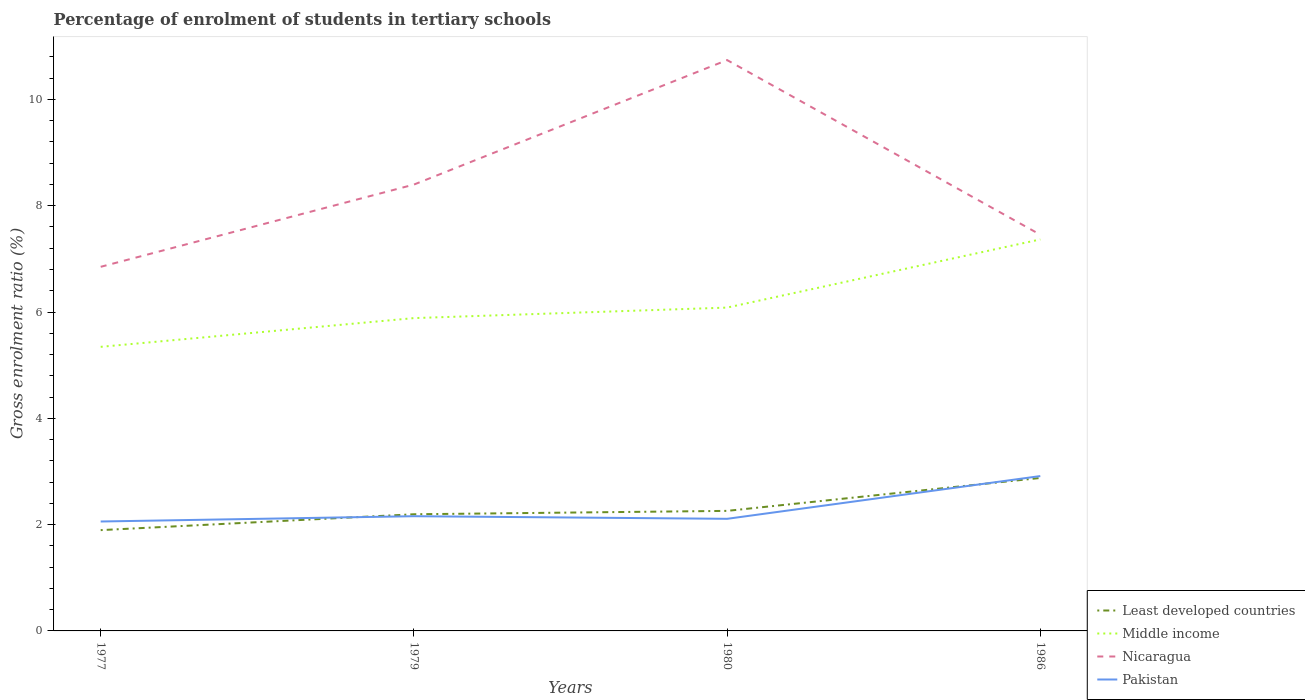How many different coloured lines are there?
Keep it short and to the point. 4. Across all years, what is the maximum percentage of students enrolled in tertiary schools in Nicaragua?
Offer a terse response. 6.85. What is the total percentage of students enrolled in tertiary schools in Middle income in the graph?
Provide a short and direct response. -0.54. What is the difference between the highest and the second highest percentage of students enrolled in tertiary schools in Nicaragua?
Your response must be concise. 3.89. Is the percentage of students enrolled in tertiary schools in Middle income strictly greater than the percentage of students enrolled in tertiary schools in Least developed countries over the years?
Ensure brevity in your answer.  No. How many lines are there?
Your answer should be compact. 4. How many years are there in the graph?
Provide a succinct answer. 4. Does the graph contain grids?
Ensure brevity in your answer.  No. Where does the legend appear in the graph?
Give a very brief answer. Bottom right. How are the legend labels stacked?
Provide a succinct answer. Vertical. What is the title of the graph?
Your answer should be very brief. Percentage of enrolment of students in tertiary schools. Does "Paraguay" appear as one of the legend labels in the graph?
Make the answer very short. No. What is the Gross enrolment ratio (%) in Least developed countries in 1977?
Offer a terse response. 1.9. What is the Gross enrolment ratio (%) in Middle income in 1977?
Offer a terse response. 5.35. What is the Gross enrolment ratio (%) in Nicaragua in 1977?
Ensure brevity in your answer.  6.85. What is the Gross enrolment ratio (%) in Pakistan in 1977?
Provide a short and direct response. 2.06. What is the Gross enrolment ratio (%) in Least developed countries in 1979?
Your response must be concise. 2.2. What is the Gross enrolment ratio (%) of Middle income in 1979?
Give a very brief answer. 5.89. What is the Gross enrolment ratio (%) of Nicaragua in 1979?
Keep it short and to the point. 8.4. What is the Gross enrolment ratio (%) of Pakistan in 1979?
Give a very brief answer. 2.16. What is the Gross enrolment ratio (%) of Least developed countries in 1980?
Your answer should be compact. 2.26. What is the Gross enrolment ratio (%) in Middle income in 1980?
Provide a short and direct response. 6.08. What is the Gross enrolment ratio (%) in Nicaragua in 1980?
Provide a short and direct response. 10.74. What is the Gross enrolment ratio (%) in Pakistan in 1980?
Provide a short and direct response. 2.11. What is the Gross enrolment ratio (%) of Least developed countries in 1986?
Keep it short and to the point. 2.88. What is the Gross enrolment ratio (%) in Middle income in 1986?
Your response must be concise. 7.37. What is the Gross enrolment ratio (%) of Nicaragua in 1986?
Your answer should be compact. 7.45. What is the Gross enrolment ratio (%) in Pakistan in 1986?
Your response must be concise. 2.91. Across all years, what is the maximum Gross enrolment ratio (%) in Least developed countries?
Your answer should be compact. 2.88. Across all years, what is the maximum Gross enrolment ratio (%) of Middle income?
Keep it short and to the point. 7.37. Across all years, what is the maximum Gross enrolment ratio (%) in Nicaragua?
Your response must be concise. 10.74. Across all years, what is the maximum Gross enrolment ratio (%) of Pakistan?
Your answer should be very brief. 2.91. Across all years, what is the minimum Gross enrolment ratio (%) in Least developed countries?
Offer a very short reply. 1.9. Across all years, what is the minimum Gross enrolment ratio (%) of Middle income?
Ensure brevity in your answer.  5.35. Across all years, what is the minimum Gross enrolment ratio (%) of Nicaragua?
Your response must be concise. 6.85. Across all years, what is the minimum Gross enrolment ratio (%) in Pakistan?
Make the answer very short. 2.06. What is the total Gross enrolment ratio (%) of Least developed countries in the graph?
Your answer should be very brief. 9.23. What is the total Gross enrolment ratio (%) of Middle income in the graph?
Ensure brevity in your answer.  24.68. What is the total Gross enrolment ratio (%) of Nicaragua in the graph?
Offer a terse response. 33.44. What is the total Gross enrolment ratio (%) in Pakistan in the graph?
Your response must be concise. 9.24. What is the difference between the Gross enrolment ratio (%) in Least developed countries in 1977 and that in 1979?
Make the answer very short. -0.3. What is the difference between the Gross enrolment ratio (%) of Middle income in 1977 and that in 1979?
Offer a very short reply. -0.54. What is the difference between the Gross enrolment ratio (%) of Nicaragua in 1977 and that in 1979?
Make the answer very short. -1.55. What is the difference between the Gross enrolment ratio (%) of Pakistan in 1977 and that in 1979?
Your answer should be very brief. -0.1. What is the difference between the Gross enrolment ratio (%) of Least developed countries in 1977 and that in 1980?
Make the answer very short. -0.36. What is the difference between the Gross enrolment ratio (%) of Middle income in 1977 and that in 1980?
Offer a very short reply. -0.74. What is the difference between the Gross enrolment ratio (%) in Nicaragua in 1977 and that in 1980?
Ensure brevity in your answer.  -3.89. What is the difference between the Gross enrolment ratio (%) of Pakistan in 1977 and that in 1980?
Keep it short and to the point. -0.05. What is the difference between the Gross enrolment ratio (%) in Least developed countries in 1977 and that in 1986?
Provide a succinct answer. -0.98. What is the difference between the Gross enrolment ratio (%) of Middle income in 1977 and that in 1986?
Offer a very short reply. -2.02. What is the difference between the Gross enrolment ratio (%) in Nicaragua in 1977 and that in 1986?
Provide a short and direct response. -0.6. What is the difference between the Gross enrolment ratio (%) of Pakistan in 1977 and that in 1986?
Offer a terse response. -0.85. What is the difference between the Gross enrolment ratio (%) of Least developed countries in 1979 and that in 1980?
Give a very brief answer. -0.06. What is the difference between the Gross enrolment ratio (%) of Middle income in 1979 and that in 1980?
Your answer should be compact. -0.2. What is the difference between the Gross enrolment ratio (%) in Nicaragua in 1979 and that in 1980?
Your answer should be very brief. -2.34. What is the difference between the Gross enrolment ratio (%) of Pakistan in 1979 and that in 1980?
Your answer should be compact. 0.05. What is the difference between the Gross enrolment ratio (%) of Least developed countries in 1979 and that in 1986?
Your answer should be very brief. -0.68. What is the difference between the Gross enrolment ratio (%) in Middle income in 1979 and that in 1986?
Your response must be concise. -1.48. What is the difference between the Gross enrolment ratio (%) of Nicaragua in 1979 and that in 1986?
Provide a succinct answer. 0.94. What is the difference between the Gross enrolment ratio (%) in Pakistan in 1979 and that in 1986?
Provide a short and direct response. -0.76. What is the difference between the Gross enrolment ratio (%) of Least developed countries in 1980 and that in 1986?
Your answer should be very brief. -0.62. What is the difference between the Gross enrolment ratio (%) in Middle income in 1980 and that in 1986?
Keep it short and to the point. -1.28. What is the difference between the Gross enrolment ratio (%) of Nicaragua in 1980 and that in 1986?
Offer a terse response. 3.29. What is the difference between the Gross enrolment ratio (%) of Pakistan in 1980 and that in 1986?
Provide a short and direct response. -0.8. What is the difference between the Gross enrolment ratio (%) of Least developed countries in 1977 and the Gross enrolment ratio (%) of Middle income in 1979?
Ensure brevity in your answer.  -3.99. What is the difference between the Gross enrolment ratio (%) of Least developed countries in 1977 and the Gross enrolment ratio (%) of Nicaragua in 1979?
Ensure brevity in your answer.  -6.5. What is the difference between the Gross enrolment ratio (%) of Least developed countries in 1977 and the Gross enrolment ratio (%) of Pakistan in 1979?
Ensure brevity in your answer.  -0.26. What is the difference between the Gross enrolment ratio (%) of Middle income in 1977 and the Gross enrolment ratio (%) of Nicaragua in 1979?
Offer a terse response. -3.05. What is the difference between the Gross enrolment ratio (%) of Middle income in 1977 and the Gross enrolment ratio (%) of Pakistan in 1979?
Your answer should be compact. 3.19. What is the difference between the Gross enrolment ratio (%) of Nicaragua in 1977 and the Gross enrolment ratio (%) of Pakistan in 1979?
Give a very brief answer. 4.69. What is the difference between the Gross enrolment ratio (%) in Least developed countries in 1977 and the Gross enrolment ratio (%) in Middle income in 1980?
Offer a very short reply. -4.19. What is the difference between the Gross enrolment ratio (%) of Least developed countries in 1977 and the Gross enrolment ratio (%) of Nicaragua in 1980?
Offer a terse response. -8.84. What is the difference between the Gross enrolment ratio (%) in Least developed countries in 1977 and the Gross enrolment ratio (%) in Pakistan in 1980?
Provide a succinct answer. -0.21. What is the difference between the Gross enrolment ratio (%) of Middle income in 1977 and the Gross enrolment ratio (%) of Nicaragua in 1980?
Offer a terse response. -5.4. What is the difference between the Gross enrolment ratio (%) in Middle income in 1977 and the Gross enrolment ratio (%) in Pakistan in 1980?
Ensure brevity in your answer.  3.24. What is the difference between the Gross enrolment ratio (%) in Nicaragua in 1977 and the Gross enrolment ratio (%) in Pakistan in 1980?
Keep it short and to the point. 4.74. What is the difference between the Gross enrolment ratio (%) of Least developed countries in 1977 and the Gross enrolment ratio (%) of Middle income in 1986?
Provide a short and direct response. -5.47. What is the difference between the Gross enrolment ratio (%) of Least developed countries in 1977 and the Gross enrolment ratio (%) of Nicaragua in 1986?
Give a very brief answer. -5.56. What is the difference between the Gross enrolment ratio (%) in Least developed countries in 1977 and the Gross enrolment ratio (%) in Pakistan in 1986?
Keep it short and to the point. -1.02. What is the difference between the Gross enrolment ratio (%) in Middle income in 1977 and the Gross enrolment ratio (%) in Nicaragua in 1986?
Ensure brevity in your answer.  -2.11. What is the difference between the Gross enrolment ratio (%) of Middle income in 1977 and the Gross enrolment ratio (%) of Pakistan in 1986?
Provide a succinct answer. 2.43. What is the difference between the Gross enrolment ratio (%) in Nicaragua in 1977 and the Gross enrolment ratio (%) in Pakistan in 1986?
Give a very brief answer. 3.94. What is the difference between the Gross enrolment ratio (%) of Least developed countries in 1979 and the Gross enrolment ratio (%) of Middle income in 1980?
Your response must be concise. -3.89. What is the difference between the Gross enrolment ratio (%) of Least developed countries in 1979 and the Gross enrolment ratio (%) of Nicaragua in 1980?
Make the answer very short. -8.55. What is the difference between the Gross enrolment ratio (%) in Least developed countries in 1979 and the Gross enrolment ratio (%) in Pakistan in 1980?
Make the answer very short. 0.09. What is the difference between the Gross enrolment ratio (%) in Middle income in 1979 and the Gross enrolment ratio (%) in Nicaragua in 1980?
Give a very brief answer. -4.85. What is the difference between the Gross enrolment ratio (%) of Middle income in 1979 and the Gross enrolment ratio (%) of Pakistan in 1980?
Keep it short and to the point. 3.78. What is the difference between the Gross enrolment ratio (%) of Nicaragua in 1979 and the Gross enrolment ratio (%) of Pakistan in 1980?
Provide a succinct answer. 6.29. What is the difference between the Gross enrolment ratio (%) of Least developed countries in 1979 and the Gross enrolment ratio (%) of Middle income in 1986?
Your answer should be compact. -5.17. What is the difference between the Gross enrolment ratio (%) in Least developed countries in 1979 and the Gross enrolment ratio (%) in Nicaragua in 1986?
Give a very brief answer. -5.26. What is the difference between the Gross enrolment ratio (%) in Least developed countries in 1979 and the Gross enrolment ratio (%) in Pakistan in 1986?
Your answer should be compact. -0.72. What is the difference between the Gross enrolment ratio (%) in Middle income in 1979 and the Gross enrolment ratio (%) in Nicaragua in 1986?
Offer a very short reply. -1.57. What is the difference between the Gross enrolment ratio (%) of Middle income in 1979 and the Gross enrolment ratio (%) of Pakistan in 1986?
Provide a succinct answer. 2.97. What is the difference between the Gross enrolment ratio (%) of Nicaragua in 1979 and the Gross enrolment ratio (%) of Pakistan in 1986?
Provide a succinct answer. 5.48. What is the difference between the Gross enrolment ratio (%) in Least developed countries in 1980 and the Gross enrolment ratio (%) in Middle income in 1986?
Offer a very short reply. -5.11. What is the difference between the Gross enrolment ratio (%) in Least developed countries in 1980 and the Gross enrolment ratio (%) in Nicaragua in 1986?
Offer a terse response. -5.2. What is the difference between the Gross enrolment ratio (%) of Least developed countries in 1980 and the Gross enrolment ratio (%) of Pakistan in 1986?
Ensure brevity in your answer.  -0.65. What is the difference between the Gross enrolment ratio (%) in Middle income in 1980 and the Gross enrolment ratio (%) in Nicaragua in 1986?
Provide a short and direct response. -1.37. What is the difference between the Gross enrolment ratio (%) in Middle income in 1980 and the Gross enrolment ratio (%) in Pakistan in 1986?
Keep it short and to the point. 3.17. What is the difference between the Gross enrolment ratio (%) of Nicaragua in 1980 and the Gross enrolment ratio (%) of Pakistan in 1986?
Offer a very short reply. 7.83. What is the average Gross enrolment ratio (%) of Least developed countries per year?
Ensure brevity in your answer.  2.31. What is the average Gross enrolment ratio (%) of Middle income per year?
Your answer should be very brief. 6.17. What is the average Gross enrolment ratio (%) of Nicaragua per year?
Offer a very short reply. 8.36. What is the average Gross enrolment ratio (%) in Pakistan per year?
Provide a short and direct response. 2.31. In the year 1977, what is the difference between the Gross enrolment ratio (%) of Least developed countries and Gross enrolment ratio (%) of Middle income?
Make the answer very short. -3.45. In the year 1977, what is the difference between the Gross enrolment ratio (%) of Least developed countries and Gross enrolment ratio (%) of Nicaragua?
Your response must be concise. -4.95. In the year 1977, what is the difference between the Gross enrolment ratio (%) of Least developed countries and Gross enrolment ratio (%) of Pakistan?
Offer a terse response. -0.16. In the year 1977, what is the difference between the Gross enrolment ratio (%) in Middle income and Gross enrolment ratio (%) in Nicaragua?
Provide a succinct answer. -1.51. In the year 1977, what is the difference between the Gross enrolment ratio (%) of Middle income and Gross enrolment ratio (%) of Pakistan?
Give a very brief answer. 3.29. In the year 1977, what is the difference between the Gross enrolment ratio (%) in Nicaragua and Gross enrolment ratio (%) in Pakistan?
Provide a short and direct response. 4.79. In the year 1979, what is the difference between the Gross enrolment ratio (%) of Least developed countries and Gross enrolment ratio (%) of Middle income?
Provide a succinct answer. -3.69. In the year 1979, what is the difference between the Gross enrolment ratio (%) of Least developed countries and Gross enrolment ratio (%) of Nicaragua?
Ensure brevity in your answer.  -6.2. In the year 1979, what is the difference between the Gross enrolment ratio (%) of Least developed countries and Gross enrolment ratio (%) of Pakistan?
Keep it short and to the point. 0.04. In the year 1979, what is the difference between the Gross enrolment ratio (%) in Middle income and Gross enrolment ratio (%) in Nicaragua?
Keep it short and to the point. -2.51. In the year 1979, what is the difference between the Gross enrolment ratio (%) in Middle income and Gross enrolment ratio (%) in Pakistan?
Your response must be concise. 3.73. In the year 1979, what is the difference between the Gross enrolment ratio (%) of Nicaragua and Gross enrolment ratio (%) of Pakistan?
Offer a terse response. 6.24. In the year 1980, what is the difference between the Gross enrolment ratio (%) of Least developed countries and Gross enrolment ratio (%) of Middle income?
Keep it short and to the point. -3.82. In the year 1980, what is the difference between the Gross enrolment ratio (%) in Least developed countries and Gross enrolment ratio (%) in Nicaragua?
Ensure brevity in your answer.  -8.48. In the year 1980, what is the difference between the Gross enrolment ratio (%) of Least developed countries and Gross enrolment ratio (%) of Pakistan?
Your answer should be very brief. 0.15. In the year 1980, what is the difference between the Gross enrolment ratio (%) of Middle income and Gross enrolment ratio (%) of Nicaragua?
Provide a succinct answer. -4.66. In the year 1980, what is the difference between the Gross enrolment ratio (%) of Middle income and Gross enrolment ratio (%) of Pakistan?
Ensure brevity in your answer.  3.97. In the year 1980, what is the difference between the Gross enrolment ratio (%) in Nicaragua and Gross enrolment ratio (%) in Pakistan?
Your answer should be very brief. 8.63. In the year 1986, what is the difference between the Gross enrolment ratio (%) of Least developed countries and Gross enrolment ratio (%) of Middle income?
Your answer should be compact. -4.49. In the year 1986, what is the difference between the Gross enrolment ratio (%) in Least developed countries and Gross enrolment ratio (%) in Nicaragua?
Offer a very short reply. -4.58. In the year 1986, what is the difference between the Gross enrolment ratio (%) of Least developed countries and Gross enrolment ratio (%) of Pakistan?
Provide a short and direct response. -0.04. In the year 1986, what is the difference between the Gross enrolment ratio (%) in Middle income and Gross enrolment ratio (%) in Nicaragua?
Offer a very short reply. -0.09. In the year 1986, what is the difference between the Gross enrolment ratio (%) in Middle income and Gross enrolment ratio (%) in Pakistan?
Keep it short and to the point. 4.45. In the year 1986, what is the difference between the Gross enrolment ratio (%) in Nicaragua and Gross enrolment ratio (%) in Pakistan?
Provide a short and direct response. 4.54. What is the ratio of the Gross enrolment ratio (%) in Least developed countries in 1977 to that in 1979?
Offer a terse response. 0.86. What is the ratio of the Gross enrolment ratio (%) of Middle income in 1977 to that in 1979?
Keep it short and to the point. 0.91. What is the ratio of the Gross enrolment ratio (%) of Nicaragua in 1977 to that in 1979?
Your answer should be compact. 0.82. What is the ratio of the Gross enrolment ratio (%) of Pakistan in 1977 to that in 1979?
Your answer should be compact. 0.95. What is the ratio of the Gross enrolment ratio (%) of Least developed countries in 1977 to that in 1980?
Give a very brief answer. 0.84. What is the ratio of the Gross enrolment ratio (%) of Middle income in 1977 to that in 1980?
Offer a very short reply. 0.88. What is the ratio of the Gross enrolment ratio (%) in Nicaragua in 1977 to that in 1980?
Ensure brevity in your answer.  0.64. What is the ratio of the Gross enrolment ratio (%) in Pakistan in 1977 to that in 1980?
Offer a terse response. 0.98. What is the ratio of the Gross enrolment ratio (%) of Least developed countries in 1977 to that in 1986?
Give a very brief answer. 0.66. What is the ratio of the Gross enrolment ratio (%) of Middle income in 1977 to that in 1986?
Make the answer very short. 0.73. What is the ratio of the Gross enrolment ratio (%) of Nicaragua in 1977 to that in 1986?
Keep it short and to the point. 0.92. What is the ratio of the Gross enrolment ratio (%) of Pakistan in 1977 to that in 1986?
Make the answer very short. 0.71. What is the ratio of the Gross enrolment ratio (%) of Least developed countries in 1979 to that in 1980?
Ensure brevity in your answer.  0.97. What is the ratio of the Gross enrolment ratio (%) in Middle income in 1979 to that in 1980?
Keep it short and to the point. 0.97. What is the ratio of the Gross enrolment ratio (%) in Nicaragua in 1979 to that in 1980?
Give a very brief answer. 0.78. What is the ratio of the Gross enrolment ratio (%) in Pakistan in 1979 to that in 1980?
Make the answer very short. 1.02. What is the ratio of the Gross enrolment ratio (%) of Least developed countries in 1979 to that in 1986?
Keep it short and to the point. 0.76. What is the ratio of the Gross enrolment ratio (%) of Middle income in 1979 to that in 1986?
Make the answer very short. 0.8. What is the ratio of the Gross enrolment ratio (%) of Nicaragua in 1979 to that in 1986?
Your answer should be compact. 1.13. What is the ratio of the Gross enrolment ratio (%) in Pakistan in 1979 to that in 1986?
Your response must be concise. 0.74. What is the ratio of the Gross enrolment ratio (%) of Least developed countries in 1980 to that in 1986?
Your response must be concise. 0.78. What is the ratio of the Gross enrolment ratio (%) of Middle income in 1980 to that in 1986?
Your response must be concise. 0.83. What is the ratio of the Gross enrolment ratio (%) in Nicaragua in 1980 to that in 1986?
Make the answer very short. 1.44. What is the ratio of the Gross enrolment ratio (%) in Pakistan in 1980 to that in 1986?
Offer a terse response. 0.72. What is the difference between the highest and the second highest Gross enrolment ratio (%) in Least developed countries?
Make the answer very short. 0.62. What is the difference between the highest and the second highest Gross enrolment ratio (%) of Middle income?
Your answer should be very brief. 1.28. What is the difference between the highest and the second highest Gross enrolment ratio (%) of Nicaragua?
Give a very brief answer. 2.34. What is the difference between the highest and the second highest Gross enrolment ratio (%) in Pakistan?
Your response must be concise. 0.76. What is the difference between the highest and the lowest Gross enrolment ratio (%) of Least developed countries?
Your response must be concise. 0.98. What is the difference between the highest and the lowest Gross enrolment ratio (%) of Middle income?
Make the answer very short. 2.02. What is the difference between the highest and the lowest Gross enrolment ratio (%) of Nicaragua?
Ensure brevity in your answer.  3.89. What is the difference between the highest and the lowest Gross enrolment ratio (%) of Pakistan?
Give a very brief answer. 0.85. 